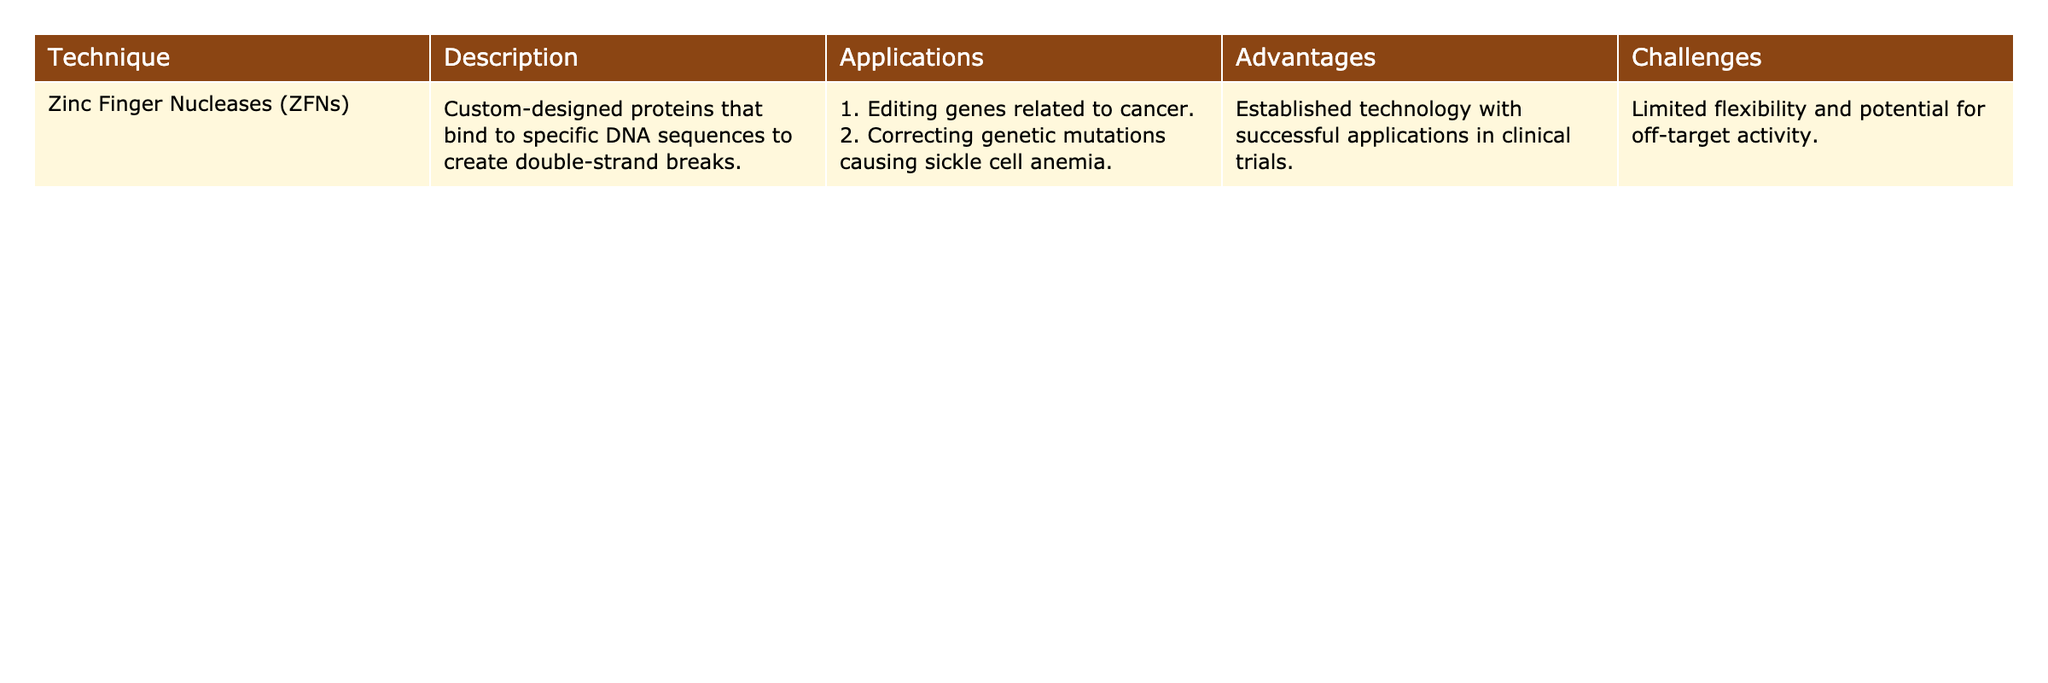What technique is used for editing genes related to cancer? The table indicates that Zinc Finger Nucleases (ZFNs) are used for editing genes related to cancer as listed under applications.
Answer: Zinc Finger Nucleases (ZFNs) What are the advantages of using Zinc Finger Nucleases (ZFNs)? The advantages listed in the table for Zinc Finger Nucleases (ZFNs) include being an established technology and successful applications in clinical trials.
Answer: Established technology; successful applications in clinical trials Is there any mention of challenges associated with Zinc Finger Nucleases (ZFNs)? Yes, the table states that the challenges include limited flexibility and potential for off-target activity.
Answer: Yes How many applications are mentioned for Zinc Finger Nucleases (ZFNs)? The table lists two applications for Zinc Finger Nucleases (ZFNs) related to cancer and sickle cell anemia.
Answer: Two applications If the flexibility of Zinc Finger Nucleases (ZFNs) is considered on a scale of 1 to 10, with 10 being highly flexible, what can be inferred from the challenges mentioned? Given that the table states ZFNs have limited flexibility, it can be inferred that they likely score low on that scale, possibly around 2 or 3.
Answer: Low flexibility What total number of advantages and challenges are outlined in the table for Zinc Finger Nucleases (ZFNs)? The table outlines one advantage (established technology) and two challenges (limited flexibility and potential for off-target activity), making a total of three.
Answer: Three What is the relationship between the established technology of ZFNs and its applications in medicine? The established technology of ZFNs indicates reliability, which supports their successful applications in medical contexts, such as gene editing related to cancer and sickle cell anemia.
Answer: Reliable technology supports applications What would happen if Zinc Finger Nucleases (ZFNs) were more flexible in terms of gene editing success? If ZFNs were more flexible, it is likely they would have fewer off-target effects and could potentially target a wider range of genes more effectively, improving their usefulness in medical applications.
Answer: Improved success in gene editing Considering the applications and challenges listed, how might off-target activity impact the use of ZFNs in clinical trials? Off-target activity could compromise the safety and efficacy of ZFNs in clinical trials, possibly leading to unintended genetic modifications and affecting patient outcomes.
Answer: Negative impact on clinical trials 